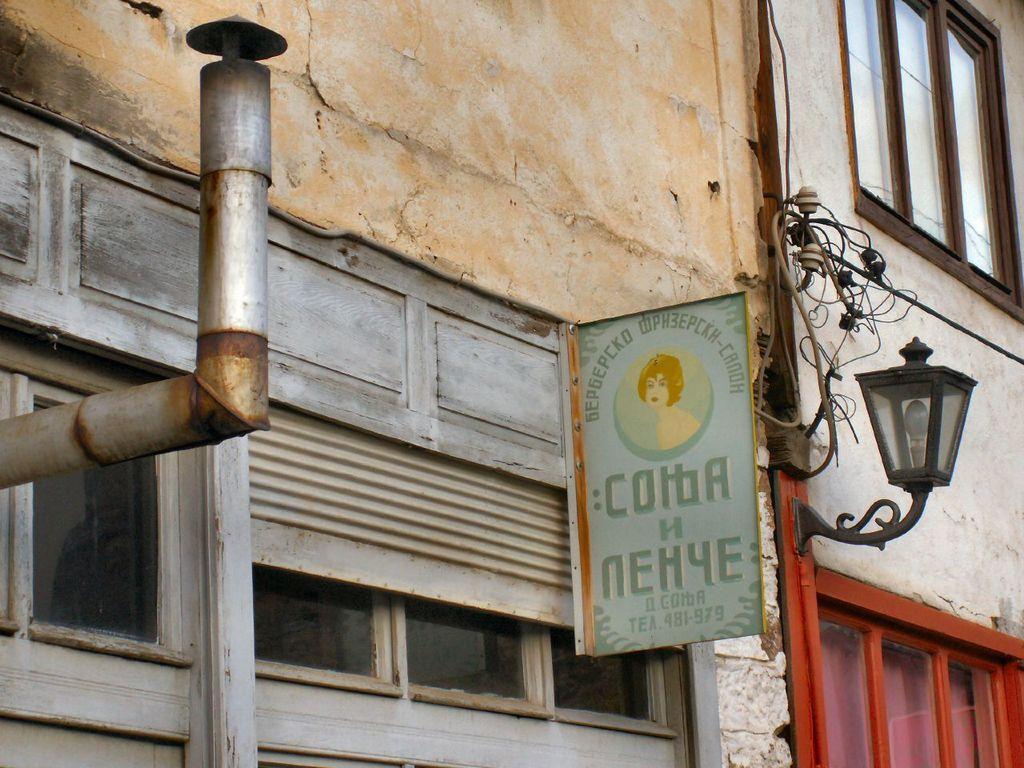What is on the building in the image? There is a hoarding on the building. What feature can be seen on the wall of the building? There are windows on the wall of the building. Can you see any swimmers in the image? There are no swimmers present in the image; it features a building with a hoarding and windows. Is there a rhythm visible in the image? There is no rhythm visible in the image; it is a static representation of a building with a hoarding and windows. 